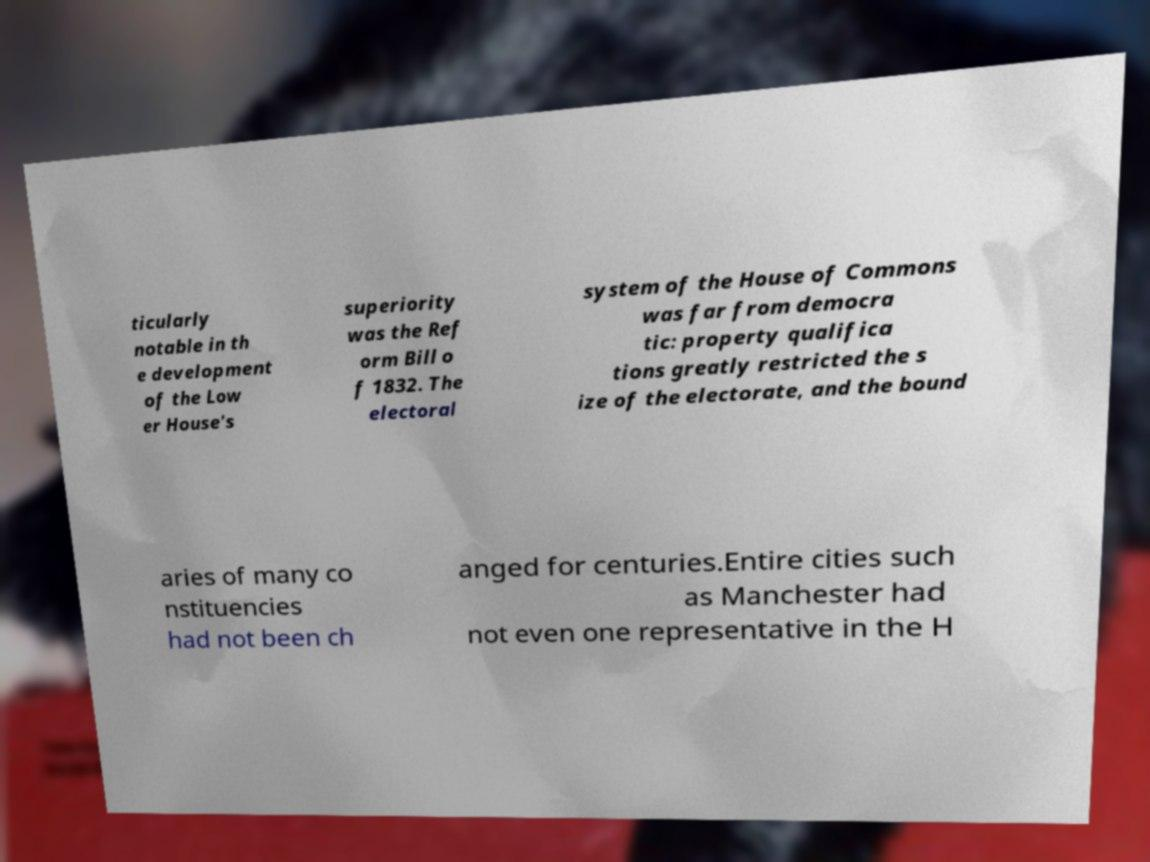Can you accurately transcribe the text from the provided image for me? ticularly notable in th e development of the Low er House's superiority was the Ref orm Bill o f 1832. The electoral system of the House of Commons was far from democra tic: property qualifica tions greatly restricted the s ize of the electorate, and the bound aries of many co nstituencies had not been ch anged for centuries.Entire cities such as Manchester had not even one representative in the H 